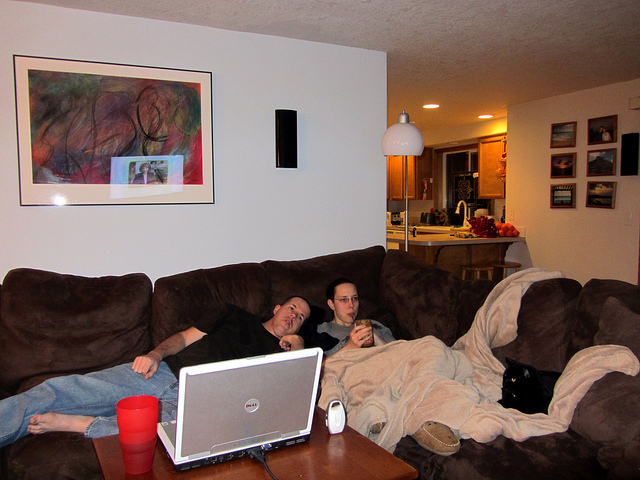<image>What is the brand of computers in the photo? The brand of the computers is unknown. However, it could be Dell. What is the brand of computers in the photo? The computers in the photo are of the brand Dell. 